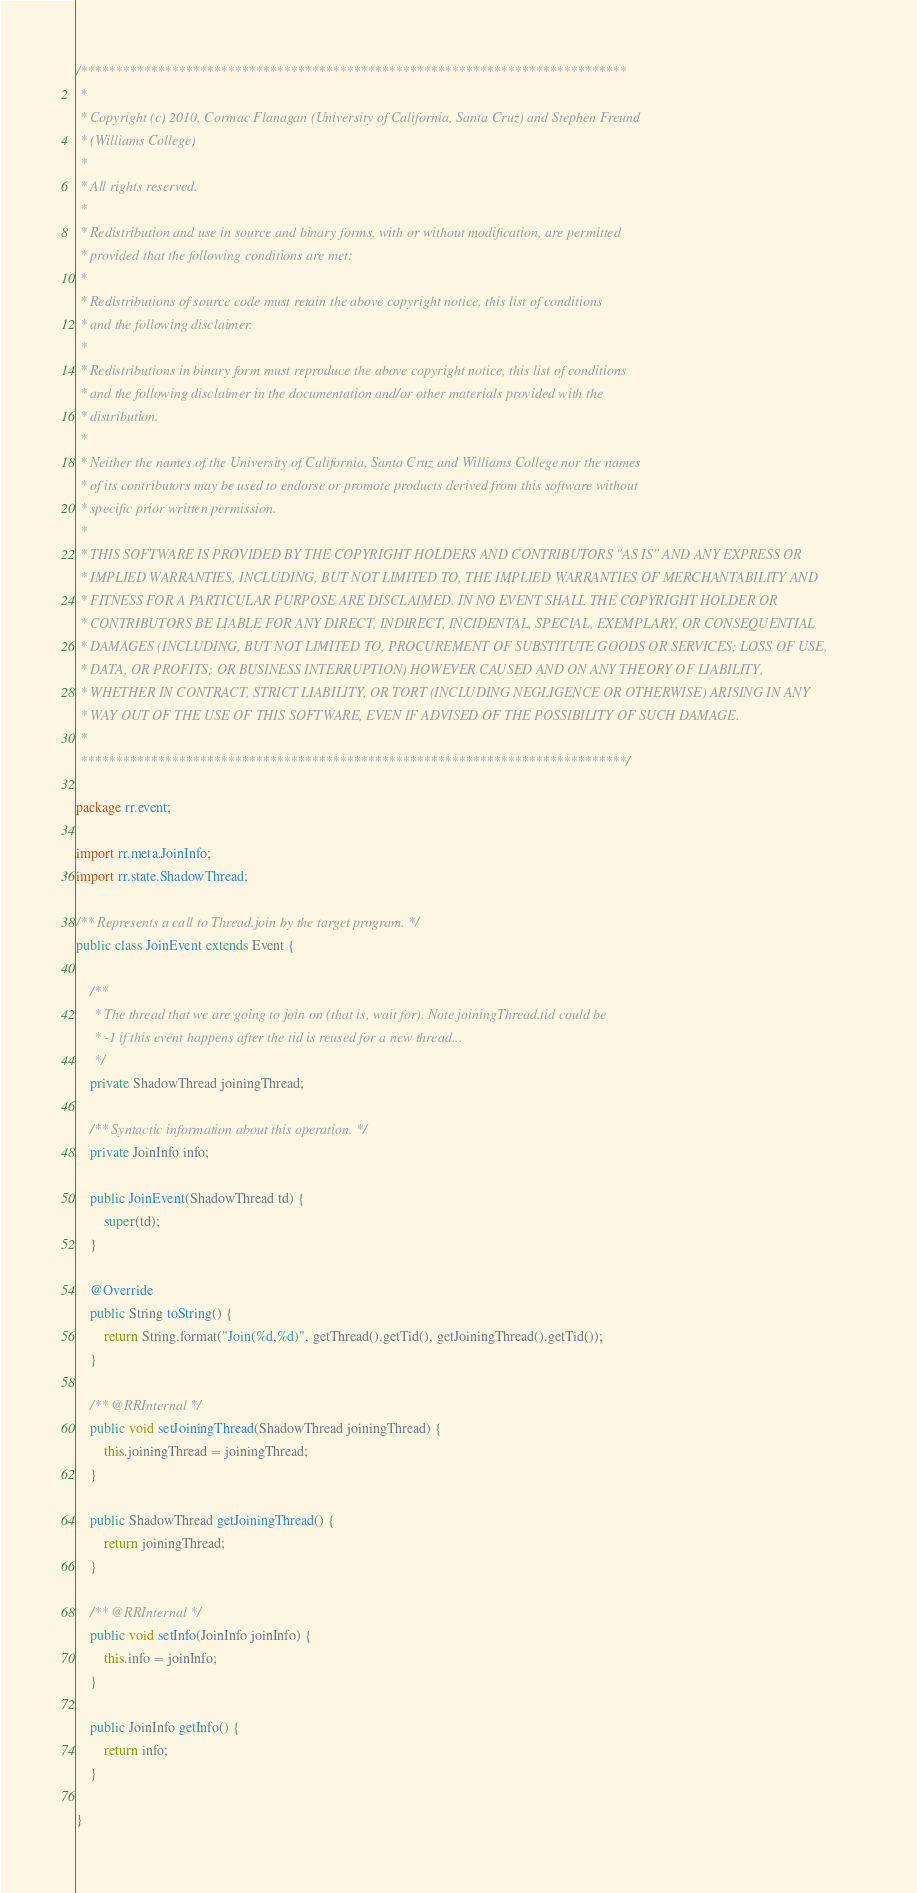<code> <loc_0><loc_0><loc_500><loc_500><_Java_>/******************************************************************************
 * 
 * Copyright (c) 2010, Cormac Flanagan (University of California, Santa Cruz) and Stephen Freund
 * (Williams College)
 * 
 * All rights reserved.
 * 
 * Redistribution and use in source and binary forms, with or without modification, are permitted
 * provided that the following conditions are met:
 * 
 * Redistributions of source code must retain the above copyright notice, this list of conditions
 * and the following disclaimer.
 * 
 * Redistributions in binary form must reproduce the above copyright notice, this list of conditions
 * and the following disclaimer in the documentation and/or other materials provided with the
 * distribution.
 * 
 * Neither the names of the University of California, Santa Cruz and Williams College nor the names
 * of its contributors may be used to endorse or promote products derived from this software without
 * specific prior written permission.
 * 
 * THIS SOFTWARE IS PROVIDED BY THE COPYRIGHT HOLDERS AND CONTRIBUTORS "AS IS" AND ANY EXPRESS OR
 * IMPLIED WARRANTIES, INCLUDING, BUT NOT LIMITED TO, THE IMPLIED WARRANTIES OF MERCHANTABILITY AND
 * FITNESS FOR A PARTICULAR PURPOSE ARE DISCLAIMED. IN NO EVENT SHALL THE COPYRIGHT HOLDER OR
 * CONTRIBUTORS BE LIABLE FOR ANY DIRECT, INDIRECT, INCIDENTAL, SPECIAL, EXEMPLARY, OR CONSEQUENTIAL
 * DAMAGES (INCLUDING, BUT NOT LIMITED TO, PROCUREMENT OF SUBSTITUTE GOODS OR SERVICES; LOSS OF USE,
 * DATA, OR PROFITS; OR BUSINESS INTERRUPTION) HOWEVER CAUSED AND ON ANY THEORY OF LIABILITY,
 * WHETHER IN CONTRACT, STRICT LIABILITY, OR TORT (INCLUDING NEGLIGENCE OR OTHERWISE) ARISING IN ANY
 * WAY OUT OF THE USE OF THIS SOFTWARE, EVEN IF ADVISED OF THE POSSIBILITY OF SUCH DAMAGE.
 * 
 ******************************************************************************/

package rr.event;

import rr.meta.JoinInfo;
import rr.state.ShadowThread;

/** Represents a call to Thread.join by the target program. */
public class JoinEvent extends Event {

    /**
     * The thread that we are going to join on (that is, wait for). Note joiningThread.tid could be
     * -1 if this event happens after the tid is reused for a new thread...
     */
    private ShadowThread joiningThread;

    /** Syntactic information about this operation. */
    private JoinInfo info;

    public JoinEvent(ShadowThread td) {
        super(td);
    }

    @Override
    public String toString() {
        return String.format("Join(%d,%d)", getThread().getTid(), getJoiningThread().getTid());
    }

    /** @RRInternal */
    public void setJoiningThread(ShadowThread joiningThread) {
        this.joiningThread = joiningThread;
    }

    public ShadowThread getJoiningThread() {
        return joiningThread;
    }

    /** @RRInternal */
    public void setInfo(JoinInfo joinInfo) {
        this.info = joinInfo;
    }

    public JoinInfo getInfo() {
        return info;
    }

}
</code> 